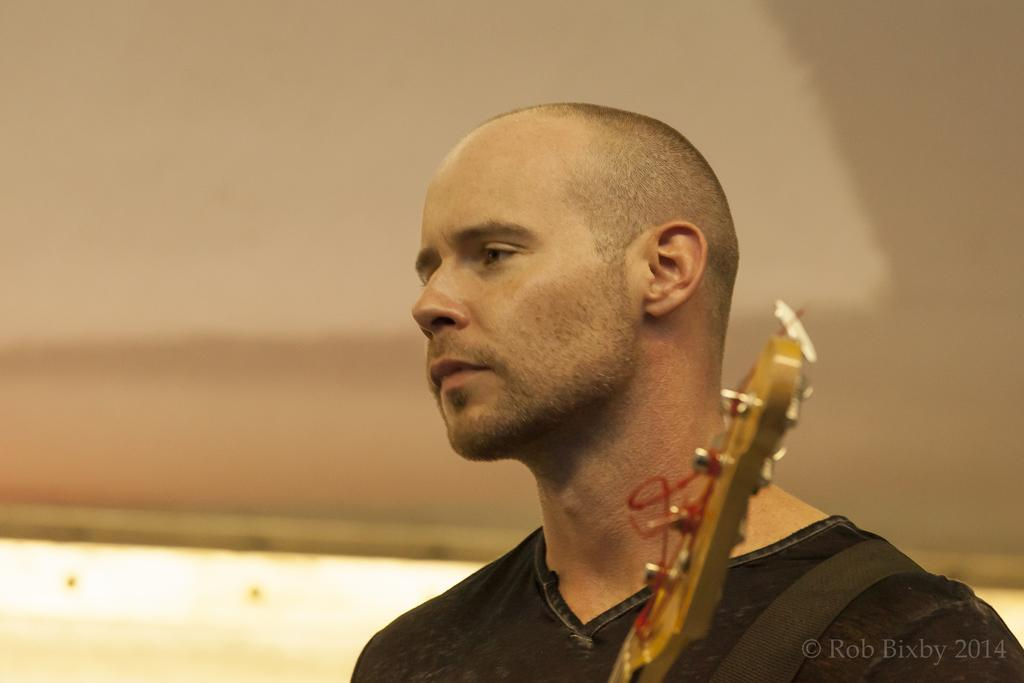What is the main subject of the image? There is a person in the image. What is the person wearing? The person is wearing a black dress. What object can be seen with the person? There is a guitar in the image. What part of the guitar is visible? The guitar has a visible head. What can be seen in the background of the image? There is a wall in the background of the image. Is there any additional information about the image itself? There is a watermark in the right bottom corner of the image. What type of destruction can be seen happening to the guitar in the image? There is no destruction happening to the guitar in the image; it appears to be in good condition. How many bubbles are visible around the person in the image? There are no bubbles visible in the image. 